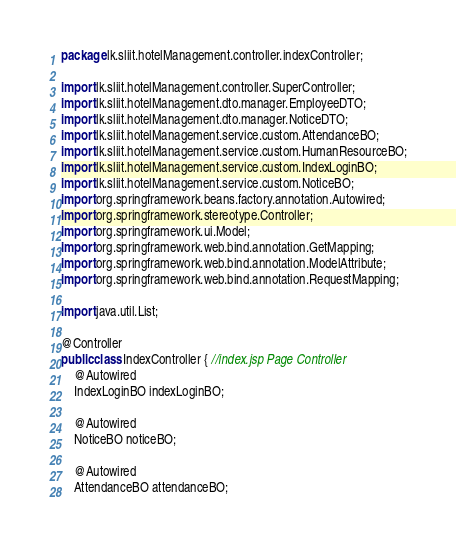Convert code to text. <code><loc_0><loc_0><loc_500><loc_500><_Java_>package lk.sliit.hotelManagement.controller.indexController;

import lk.sliit.hotelManagement.controller.SuperController;
import lk.sliit.hotelManagement.dto.manager.EmployeeDTO;
import lk.sliit.hotelManagement.dto.manager.NoticeDTO;
import lk.sliit.hotelManagement.service.custom.AttendanceBO;
import lk.sliit.hotelManagement.service.custom.HumanResourceBO;
import lk.sliit.hotelManagement.service.custom.IndexLoginBO;
import lk.sliit.hotelManagement.service.custom.NoticeBO;
import org.springframework.beans.factory.annotation.Autowired;
import org.springframework.stereotype.Controller;
import org.springframework.ui.Model;
import org.springframework.web.bind.annotation.GetMapping;
import org.springframework.web.bind.annotation.ModelAttribute;
import org.springframework.web.bind.annotation.RequestMapping;

import java.util.List;

@Controller
public class IndexController { //index.jsp Page Controller
    @Autowired
    IndexLoginBO indexLoginBO;

    @Autowired
    NoticeBO noticeBO;

    @Autowired
    AttendanceBO attendanceBO;</code> 